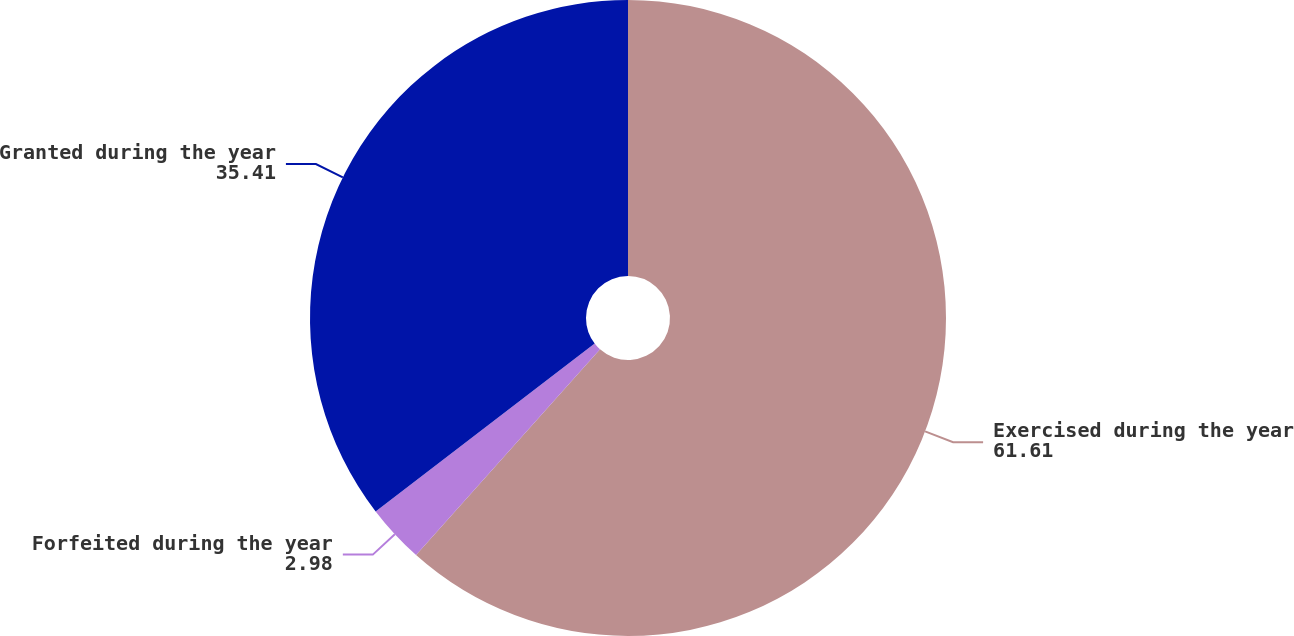<chart> <loc_0><loc_0><loc_500><loc_500><pie_chart><fcel>Exercised during the year<fcel>Forfeited during the year<fcel>Granted during the year<nl><fcel>61.61%<fcel>2.98%<fcel>35.41%<nl></chart> 